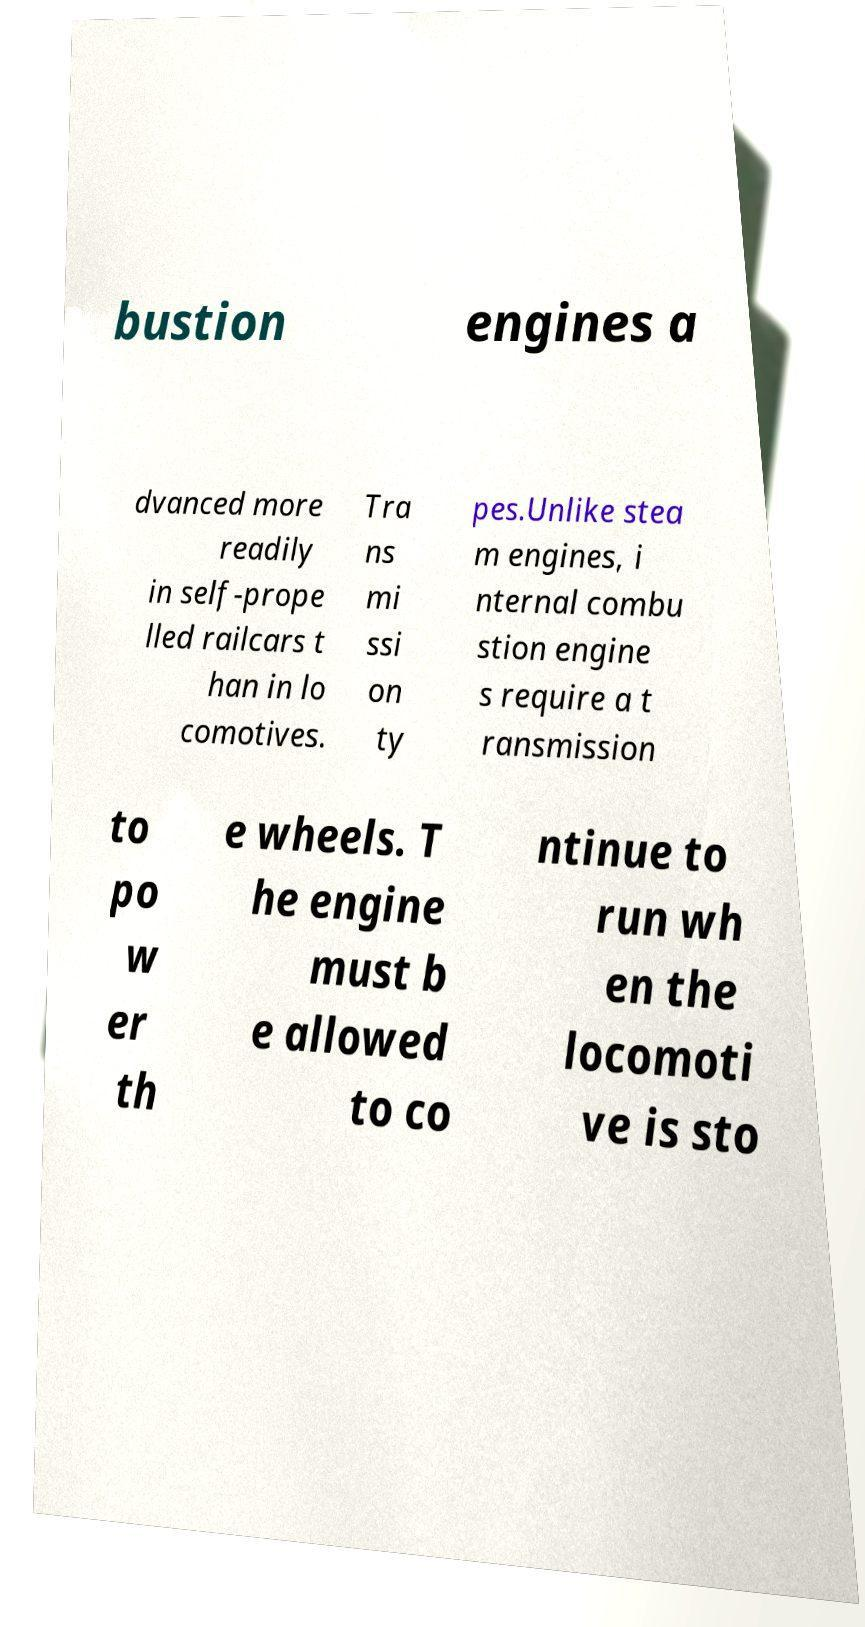Please identify and transcribe the text found in this image. bustion engines a dvanced more readily in self-prope lled railcars t han in lo comotives. Tra ns mi ssi on ty pes.Unlike stea m engines, i nternal combu stion engine s require a t ransmission to po w er th e wheels. T he engine must b e allowed to co ntinue to run wh en the locomoti ve is sto 